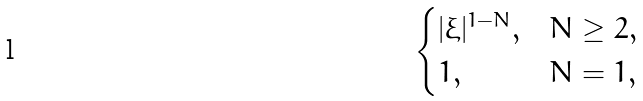Convert formula to latex. <formula><loc_0><loc_0><loc_500><loc_500>\begin{cases} | \xi | ^ { 1 - N } , & N \geq 2 , \\ 1 , & N = 1 , \end{cases}</formula> 